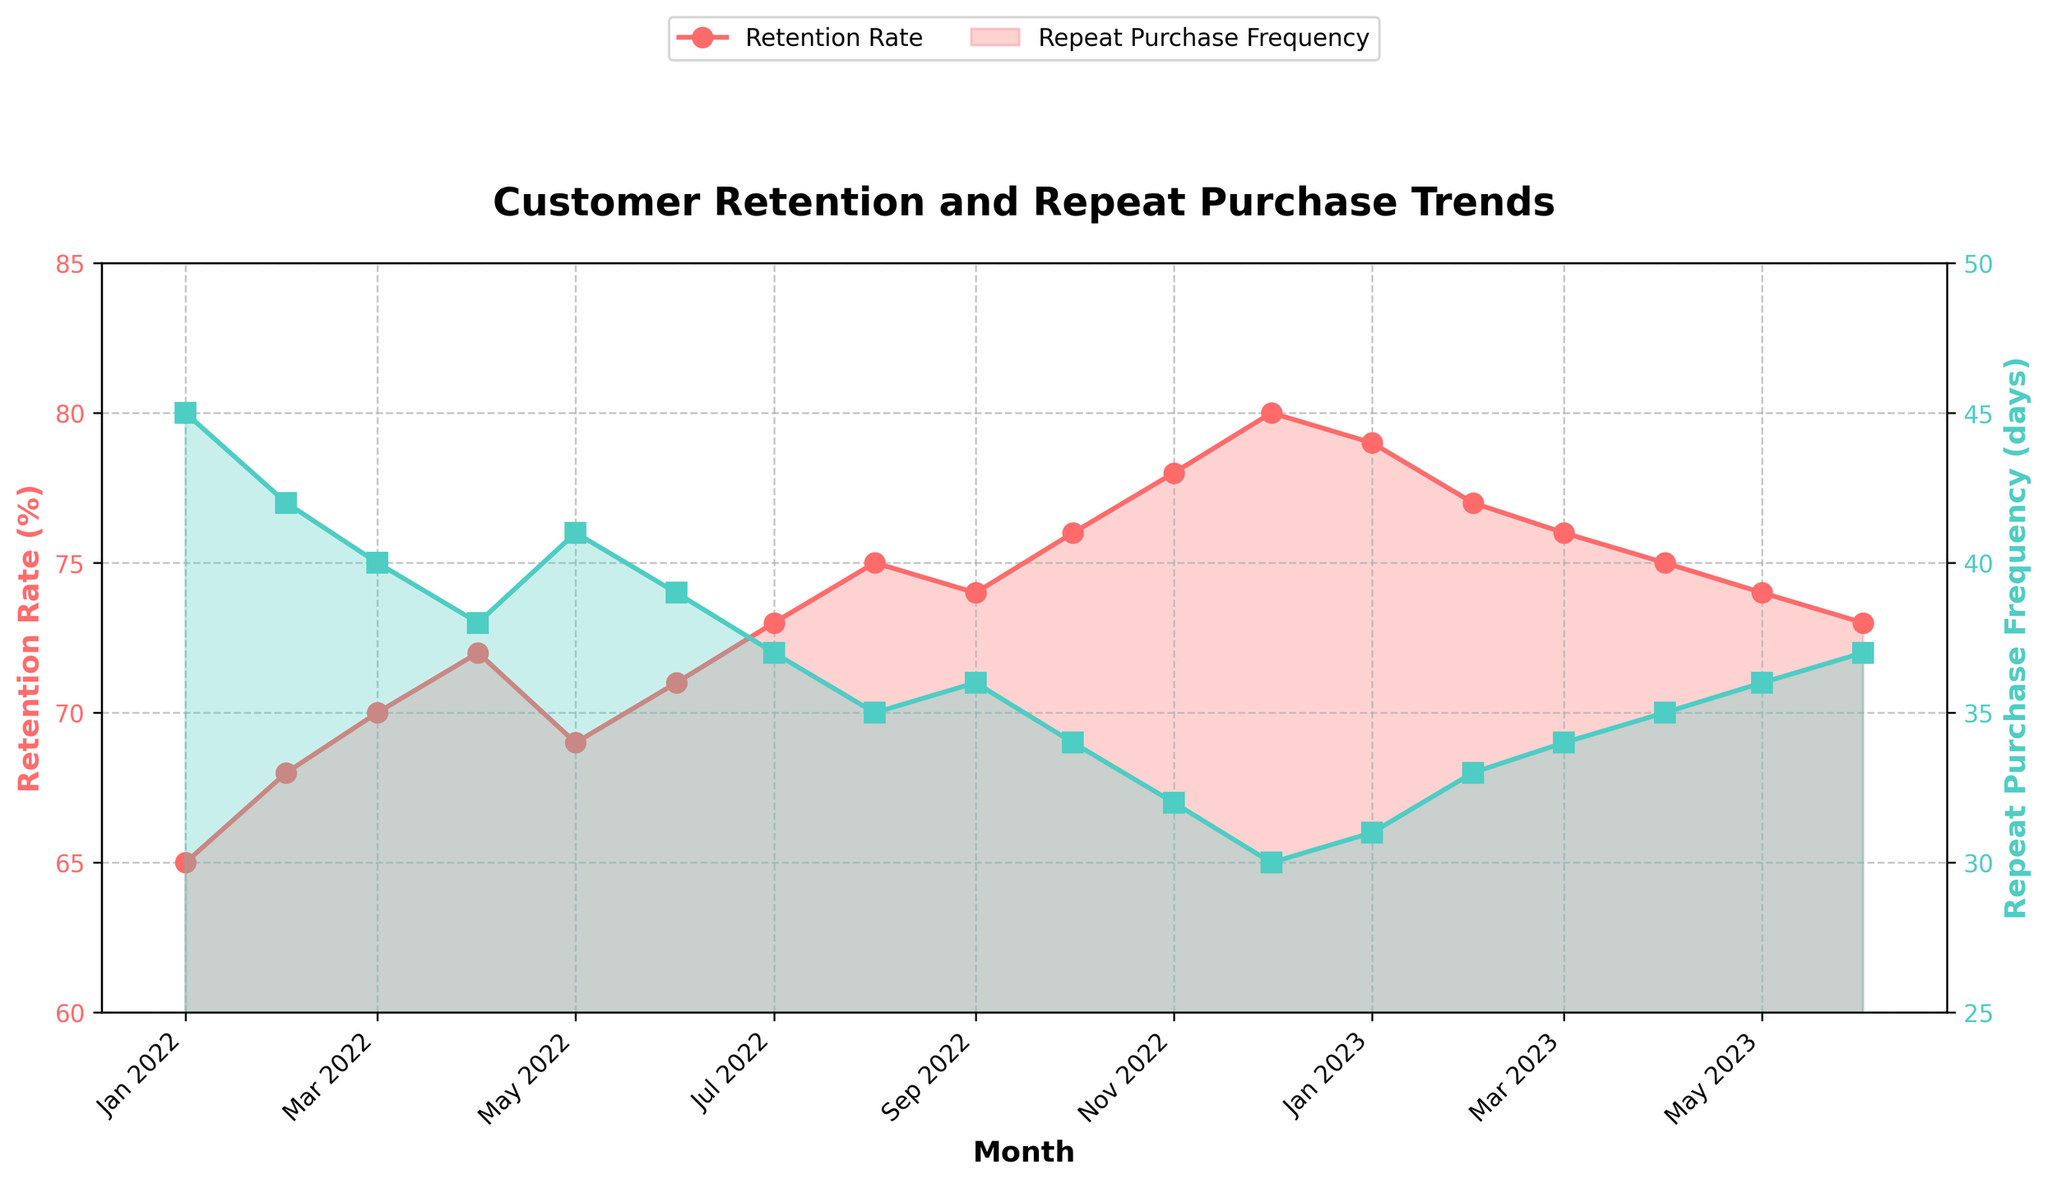Which month has the lowest repeat purchase frequency? The repeat purchase frequency is lowest when the marker is at its lowest position on the vertical axis with the green color. We can see that December 2022 has the lowest point on the green line indicating 30 days.
Answer: December 2022 Which month had the highest retention rate, and what was the rate? The retention rate is highest when the marker on the red line is positioned at its highest point. By looking at the red line, we can see that December 2022 had the highest retention rate at 80%.
Answer: December 2022, 80% How much did the retention rate change from January 2022 to January 2023? To find the difference in retention rates, we subtract the January 2022 value from the January 2023 value. January 2022 had a retention rate of 65%, and January 2023 had a rate of 79%. So, the change is 79% - 65% = 14%.
Answer: 14% Which month shows the greatest decline in retention rate compared to its previous month? To identify the month with the greatest decline, we need to examine the red line and observe the steepest drop. The biggest decline occurred from December 2022 (80%) to January 2023 (79%), which is a 1% drop. Other decreases between months are less than 1%.
Answer: January 2023 What is the average repeat purchase frequency across the entire period? Summing up all the repeat purchase frequencies over the given months and dividing by the number of months gives the average. The sum is 45 + 42 + 40 + 38 + 41 + 39 + 37 + 35 + 36 + 34 + 32 + 30 + 31 + 33 + 34 + 35 + 36 + 37 = 676. There are 18 months, so the average is 676/18 ≈ 37.56 days.
Answer: 37.56 days During which months did the retention rate consistently increase, and repeat purchase frequency consistently decrease? We need to find a continuous period where the red line (retention rate) is always rising and the green line (purchase frequency) is always falling. From July 2022 to December 2022, the retention rate increases consistently from 73% to 80% and the repeat purchase frequency decreases consistently from 37 days to 30 days.
Answer: July 2022 to December 2022 Compare the repeat purchase frequency in June 2022 to June 2023, and identify the change. The repeat purchase frequency in June 2022 was 39 days, and in June 2023, it was 37 days. Subtracting the latter from the former gives 39 - 37 = 2 days.
Answer: 2 days Is there any month where both the retention rate and repeat purchase frequency remained unchanged from the previous month? Observing the red and green lines month by month, we see that both lines change every month without staying flat, meaning there's no month where both metrics remained unchanged.
Answer: No 